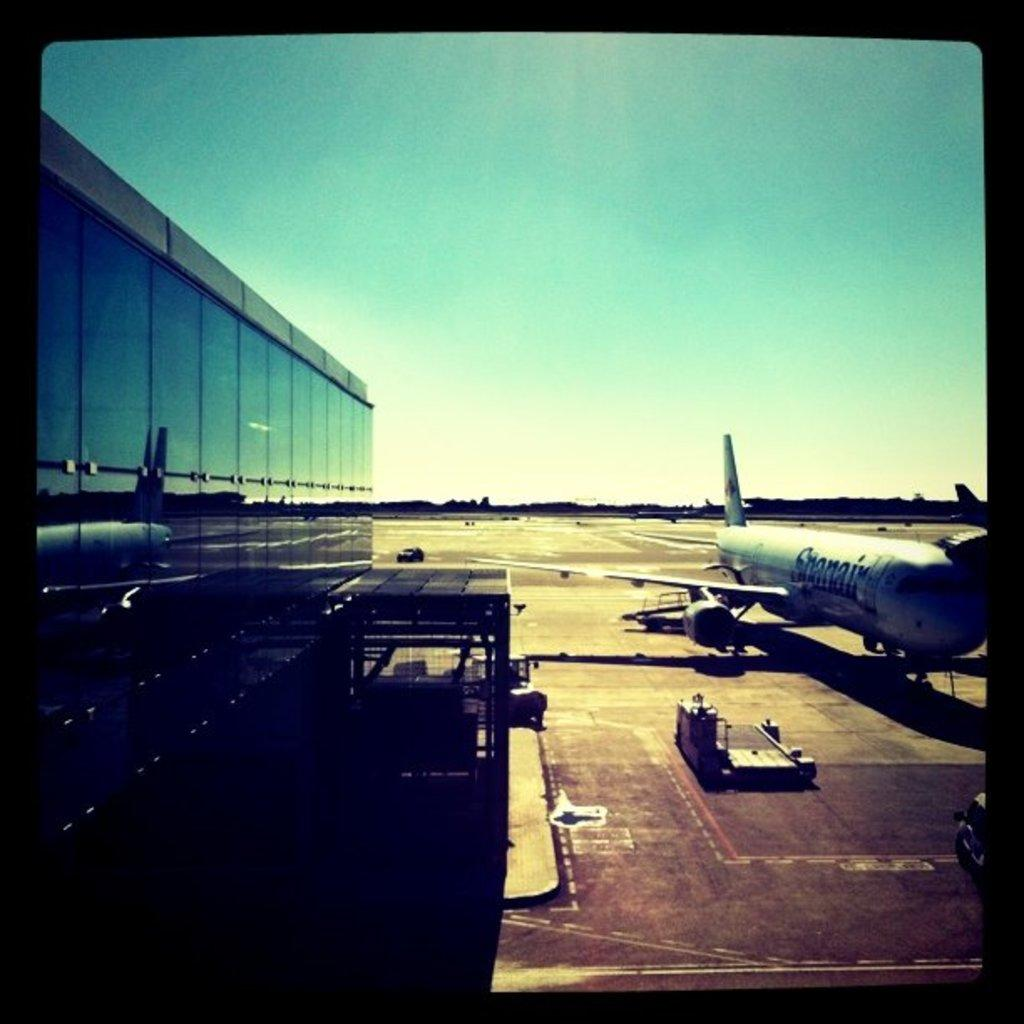What can be observed about the image in terms of editing? The image is edited. What type of vehicle is located on the land in the image? There is an airplane on the land in the image. What other vehicle is present in the image? There is a truck beside the airplane in the image. What structure can be seen on the left side of the image? There is a building on the left side of the image. What type of weather condition, such as sleet, can be seen in the bedroom in the image? There is no bedroom or weather condition mentioned in the image; it features an airplane, truck, and building. 